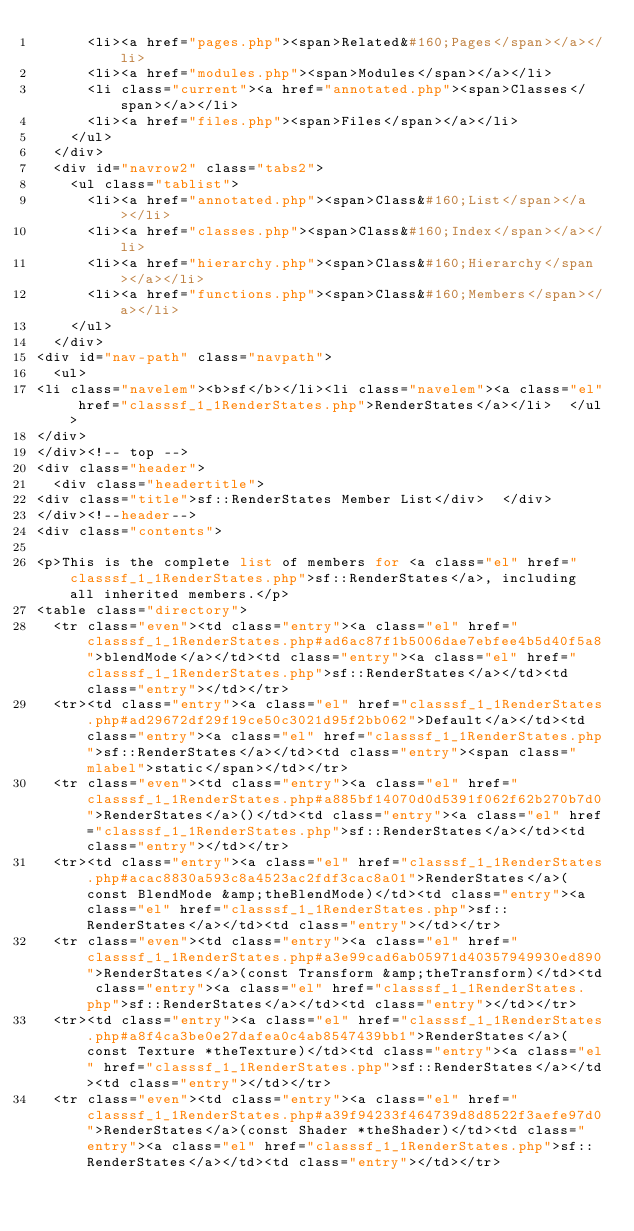Convert code to text. <code><loc_0><loc_0><loc_500><loc_500><_PHP_>      <li><a href="pages.php"><span>Related&#160;Pages</span></a></li>
      <li><a href="modules.php"><span>Modules</span></a></li>
      <li class="current"><a href="annotated.php"><span>Classes</span></a></li>
      <li><a href="files.php"><span>Files</span></a></li>
    </ul>
  </div>
  <div id="navrow2" class="tabs2">
    <ul class="tablist">
      <li><a href="annotated.php"><span>Class&#160;List</span></a></li>
      <li><a href="classes.php"><span>Class&#160;Index</span></a></li>
      <li><a href="hierarchy.php"><span>Class&#160;Hierarchy</span></a></li>
      <li><a href="functions.php"><span>Class&#160;Members</span></a></li>
    </ul>
  </div>
<div id="nav-path" class="navpath">
  <ul>
<li class="navelem"><b>sf</b></li><li class="navelem"><a class="el" href="classsf_1_1RenderStates.php">RenderStates</a></li>  </ul>
</div>
</div><!-- top -->
<div class="header">
  <div class="headertitle">
<div class="title">sf::RenderStates Member List</div>  </div>
</div><!--header-->
<div class="contents">

<p>This is the complete list of members for <a class="el" href="classsf_1_1RenderStates.php">sf::RenderStates</a>, including all inherited members.</p>
<table class="directory">
  <tr class="even"><td class="entry"><a class="el" href="classsf_1_1RenderStates.php#ad6ac87f1b5006dae7ebfee4b5d40f5a8">blendMode</a></td><td class="entry"><a class="el" href="classsf_1_1RenderStates.php">sf::RenderStates</a></td><td class="entry"></td></tr>
  <tr><td class="entry"><a class="el" href="classsf_1_1RenderStates.php#ad29672df29f19ce50c3021d95f2bb062">Default</a></td><td class="entry"><a class="el" href="classsf_1_1RenderStates.php">sf::RenderStates</a></td><td class="entry"><span class="mlabel">static</span></td></tr>
  <tr class="even"><td class="entry"><a class="el" href="classsf_1_1RenderStates.php#a885bf14070d0d5391f062f62b270b7d0">RenderStates</a>()</td><td class="entry"><a class="el" href="classsf_1_1RenderStates.php">sf::RenderStates</a></td><td class="entry"></td></tr>
  <tr><td class="entry"><a class="el" href="classsf_1_1RenderStates.php#acac8830a593c8a4523ac2fdf3cac8a01">RenderStates</a>(const BlendMode &amp;theBlendMode)</td><td class="entry"><a class="el" href="classsf_1_1RenderStates.php">sf::RenderStates</a></td><td class="entry"></td></tr>
  <tr class="even"><td class="entry"><a class="el" href="classsf_1_1RenderStates.php#a3e99cad6ab05971d40357949930ed890">RenderStates</a>(const Transform &amp;theTransform)</td><td class="entry"><a class="el" href="classsf_1_1RenderStates.php">sf::RenderStates</a></td><td class="entry"></td></tr>
  <tr><td class="entry"><a class="el" href="classsf_1_1RenderStates.php#a8f4ca3be0e27dafea0c4ab8547439bb1">RenderStates</a>(const Texture *theTexture)</td><td class="entry"><a class="el" href="classsf_1_1RenderStates.php">sf::RenderStates</a></td><td class="entry"></td></tr>
  <tr class="even"><td class="entry"><a class="el" href="classsf_1_1RenderStates.php#a39f94233f464739d8d8522f3aefe97d0">RenderStates</a>(const Shader *theShader)</td><td class="entry"><a class="el" href="classsf_1_1RenderStates.php">sf::RenderStates</a></td><td class="entry"></td></tr></code> 